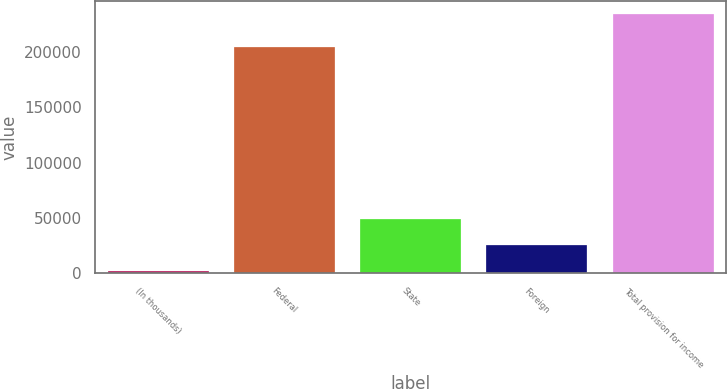Convert chart to OTSL. <chart><loc_0><loc_0><loc_500><loc_500><bar_chart><fcel>(In thousands)<fcel>Federal<fcel>State<fcel>Foreign<fcel>Total provision for income<nl><fcel>2006<fcel>204289<fcel>48523.2<fcel>25264.6<fcel>234592<nl></chart> 